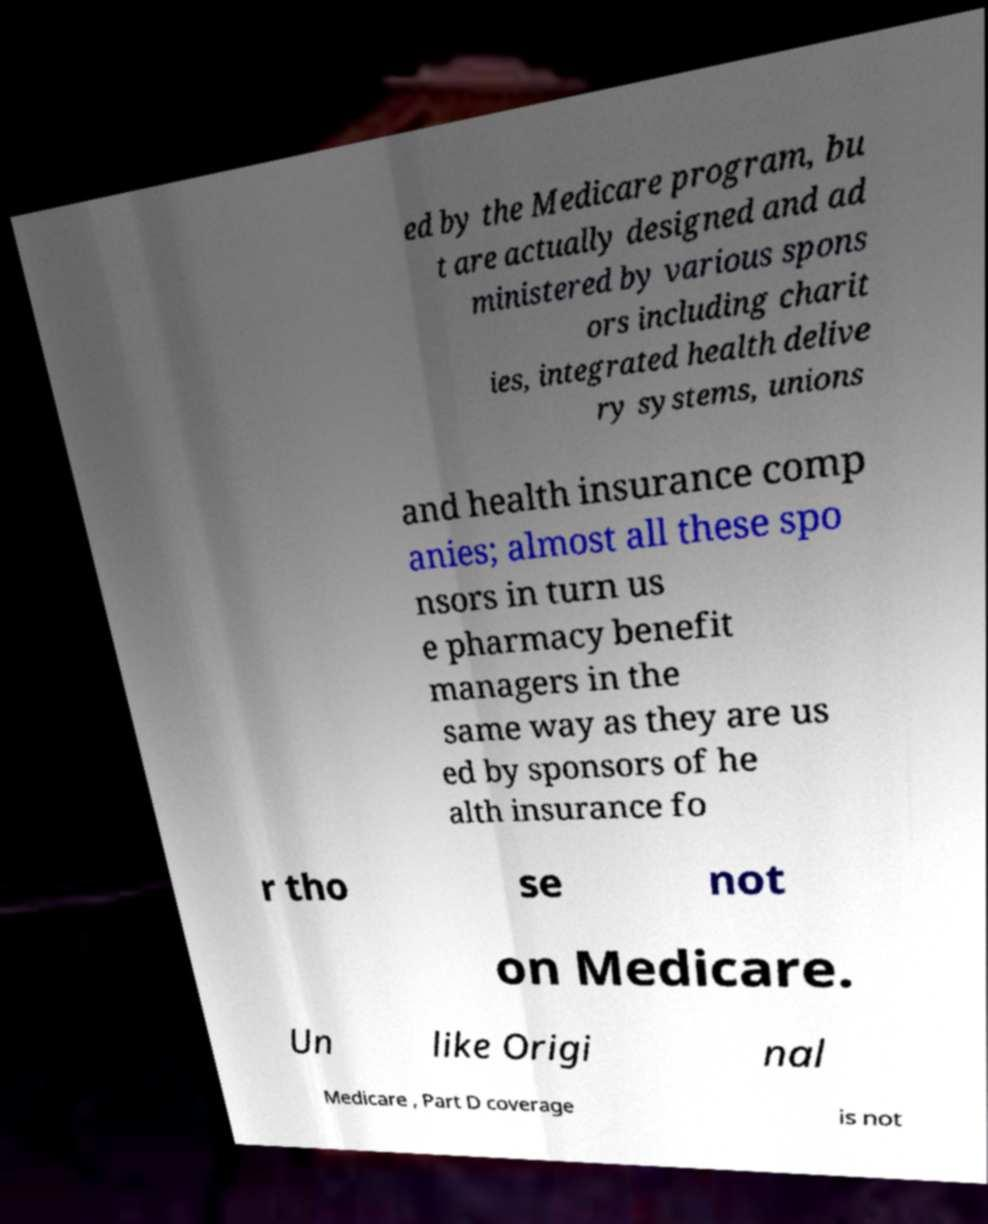Please identify and transcribe the text found in this image. ed by the Medicare program, bu t are actually designed and ad ministered by various spons ors including charit ies, integrated health delive ry systems, unions and health insurance comp anies; almost all these spo nsors in turn us e pharmacy benefit managers in the same way as they are us ed by sponsors of he alth insurance fo r tho se not on Medicare. Un like Origi nal Medicare , Part D coverage is not 